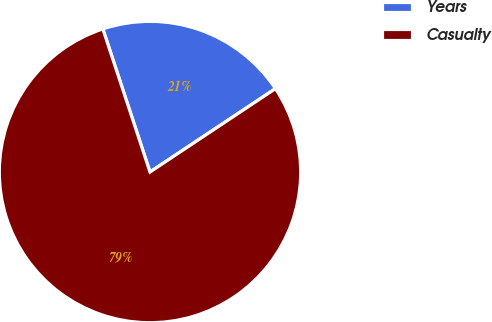Convert chart to OTSL. <chart><loc_0><loc_0><loc_500><loc_500><pie_chart><fcel>Years<fcel>Casualty<nl><fcel>20.73%<fcel>79.27%<nl></chart> 